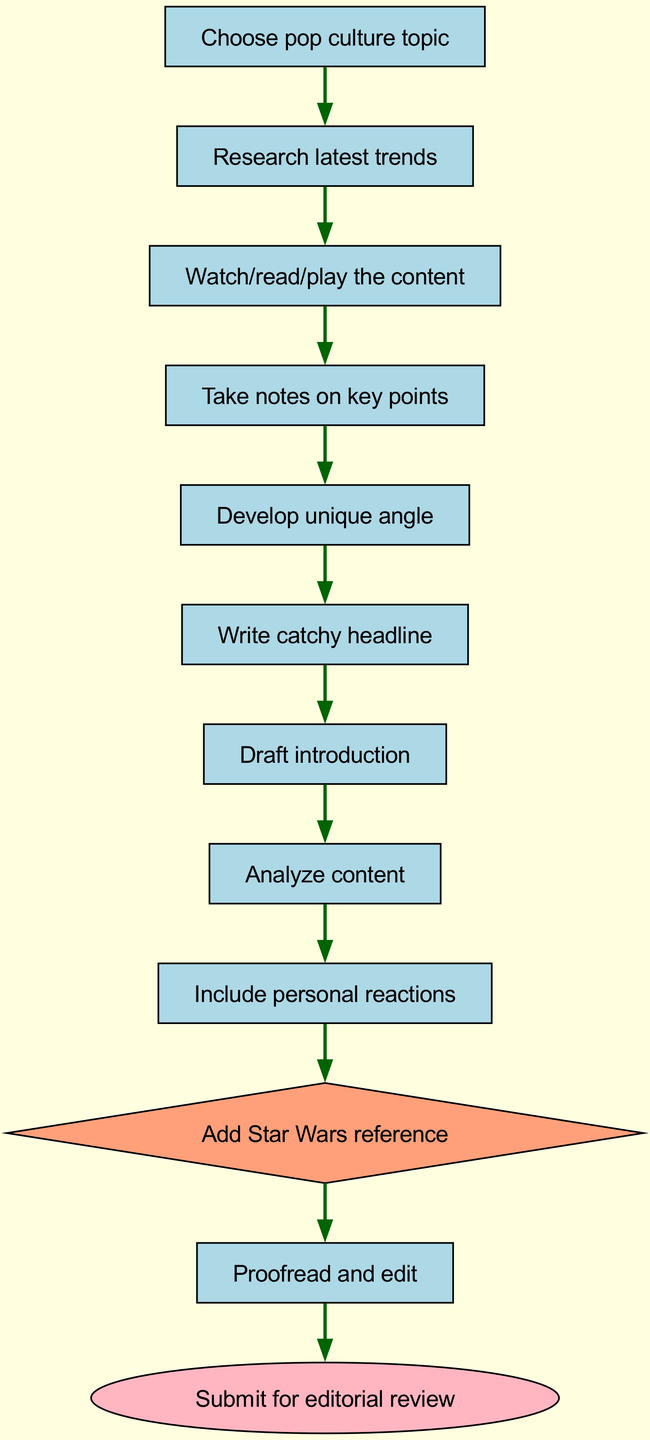What is the first step in the process? The first step is represented by the start node, which is labeled as "Choose pop culture topic". This is indicated by the flowchart structure as the source point for the process.
Answer: Choose pop culture topic How many nodes are in the diagram? To determine the number of nodes, we count each unique step from start to finish shown in the diagram. There are a total of 11 nodes mentioned in the data.
Answer: 11 What follows after "Draft introduction"? The edge from "Draft introduction" leads to the next step, which is labeled as "Analyze content". This is a direct connection indicating the sequence of actions to follow.
Answer: Analyze content Which node is represented as a diamond? The node labeled "Add Star Wars reference" is highlighted as a diamond shape in the diagram, indicating a special step in the process that may require emphasis or a decision to be made.
Answer: Add Star Wars reference What is the final step indicated in the process? The last node after all preceding actions is "Submit for editorial review". This signifies the completion of the entire process flow before final submission.
Answer: Submit for editorial review After "Analyze content", what are the next two nodes? Following "Analyze content", the next steps follow the edges leading to "Include personal reactions", and then to "Add Star Wars reference". This sequence can be traced by examining the connections established by the edges.
Answer: Include personal reactions, Add Star Wars reference Is "Research latest trends" a terminating step in the flow? No, "Research latest trends" is not a terminating step; it is an initial action that leads to subsequent steps, as indicated by the flow from that node to "Watch/read/play the content." It is part of a larger process.
Answer: No How many edges connect the nodes in the flowchart? The edges indicate connections between the nodes, representing the flow of the process. Counting the edges based on the provided data shows there are 10 edges connecting those nodes.
Answer: 10 